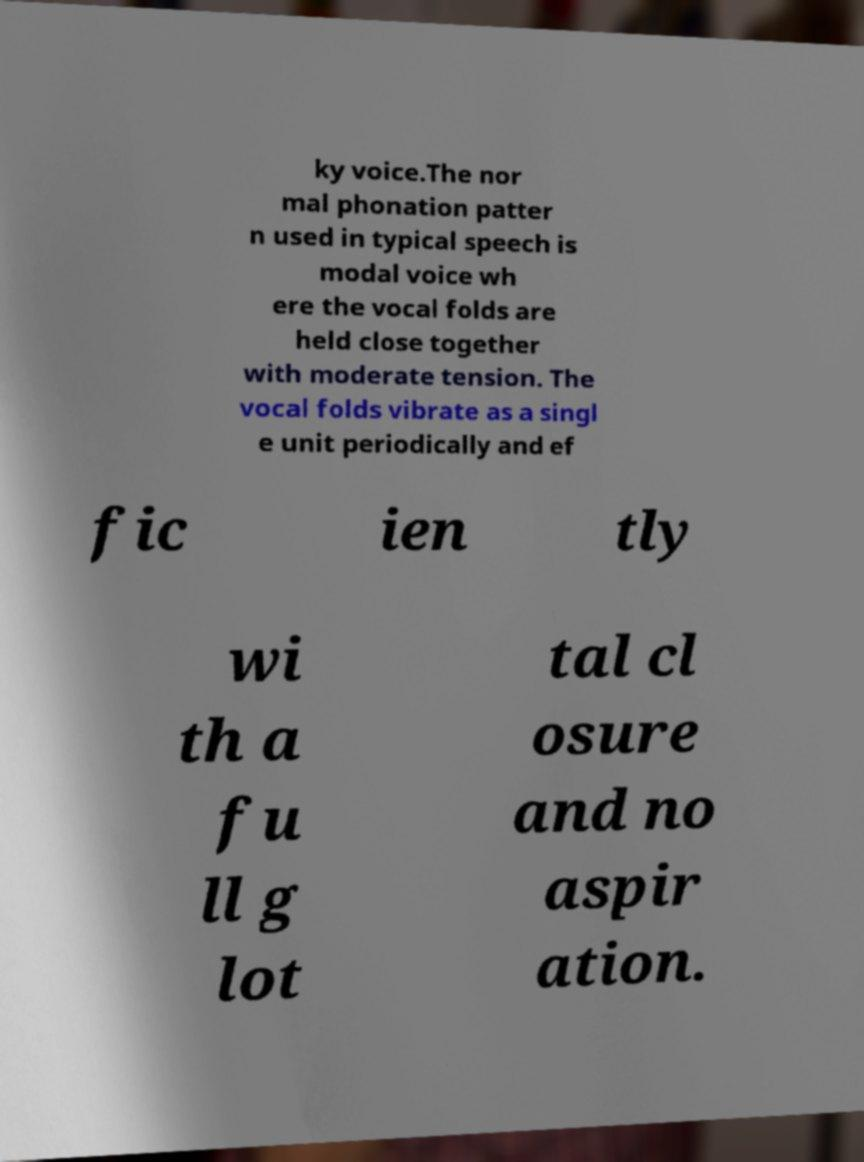For documentation purposes, I need the text within this image transcribed. Could you provide that? ky voice.The nor mal phonation patter n used in typical speech is modal voice wh ere the vocal folds are held close together with moderate tension. The vocal folds vibrate as a singl e unit periodically and ef fic ien tly wi th a fu ll g lot tal cl osure and no aspir ation. 